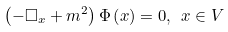Convert formula to latex. <formula><loc_0><loc_0><loc_500><loc_500>\left ( - \square _ { x } + m ^ { 2 } \right ) \Phi \left ( x \right ) = 0 , \ x \in V</formula> 